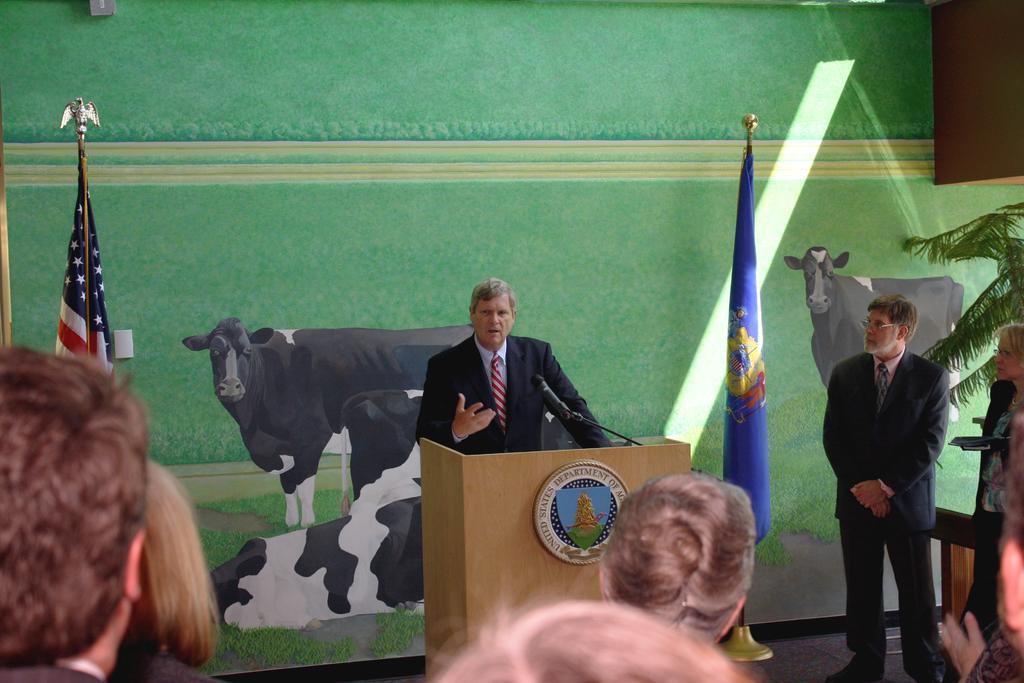Could you give a brief overview of what you see in this image? In this picture there is a man in the center of the image and there is a mic and a desk in front of him, there is a flag on the left side of the image and there is a plant on the right side of the image, there are people at the bottom side of the image, there is a painting in the background area of the image. 